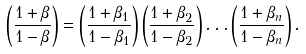<formula> <loc_0><loc_0><loc_500><loc_500>\left ( \frac { 1 + \beta } { 1 - \beta } \right ) = \left ( \frac { 1 + \beta _ { 1 } } { 1 - \beta _ { 1 } } \right ) \left ( \frac { 1 + \beta _ { 2 } } { 1 - \beta _ { 2 } } \right ) \dots \left ( \frac { 1 + \beta _ { n } } { 1 - \beta _ { n } } \right ) .</formula> 